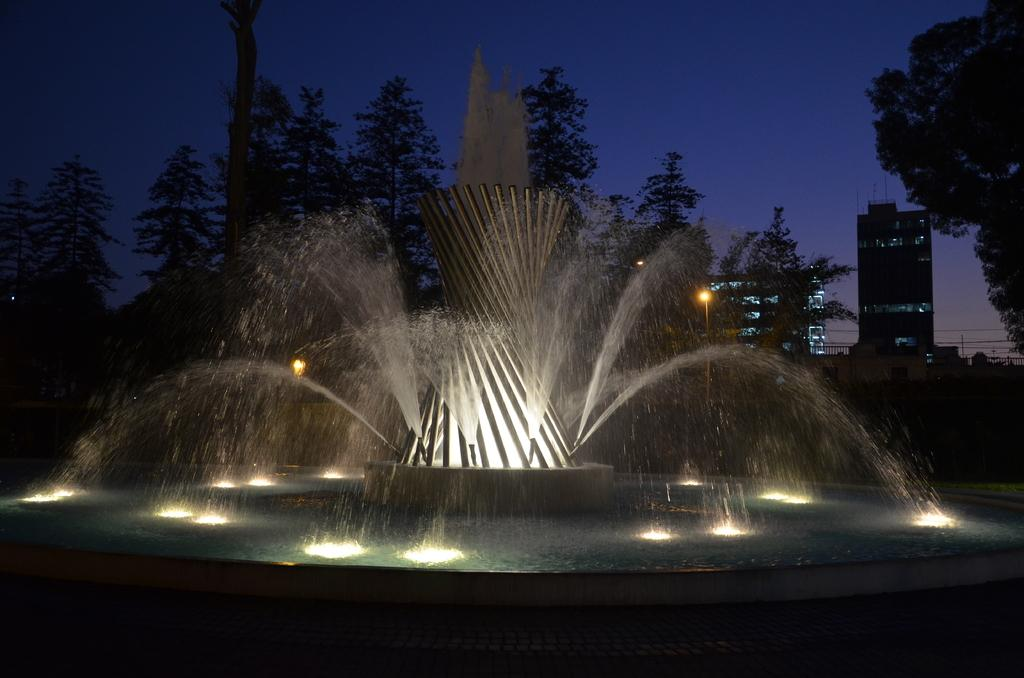What is the main feature in the image? There is a fountain in the image. What type of natural elements can be seen in the image? There are many trees in the image. How many lights are visible in the image? There are few lights in the image. How many buildings can be seen in the image? There are few buildings in the image. What part of the natural environment is visible in the image? The sky is visible in the image. What type of substance is the toad using to cross the fountain in the image? There is no toad present in the image, so it is not possible to determine what substance it might be using to cross the fountain. 